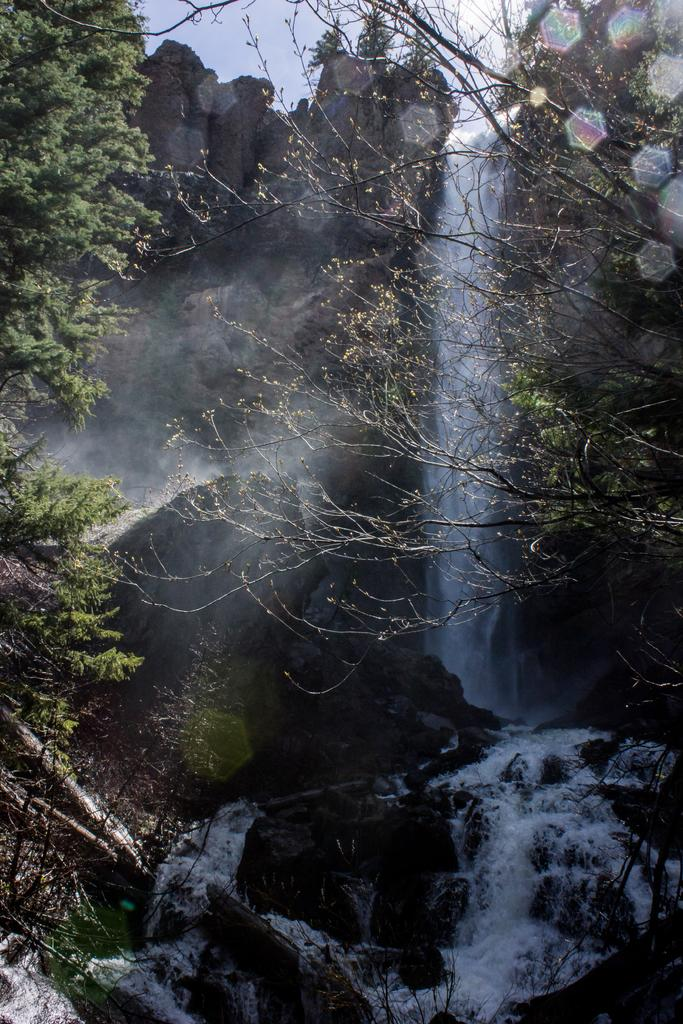What type of natural feature can be seen on the left side of the image? There are trees on a hill on the left side of the image. What type of natural feature can be seen on the right side of the image? There are trees on a hill on the right side of the image. What is the source of the water in the image? The waterfall is coming from a mountain in the background of the image. What is visible in the sky in the image? The sky is visible in the background of the image. What type of ticket is required to enter the waterfall in the image? There is no mention of a ticket or any requirement to enter the waterfall in the image. What type of oil is used to maintain the trees in the image? There is no mention of oil or any maintenance activity for the trees in the image. 